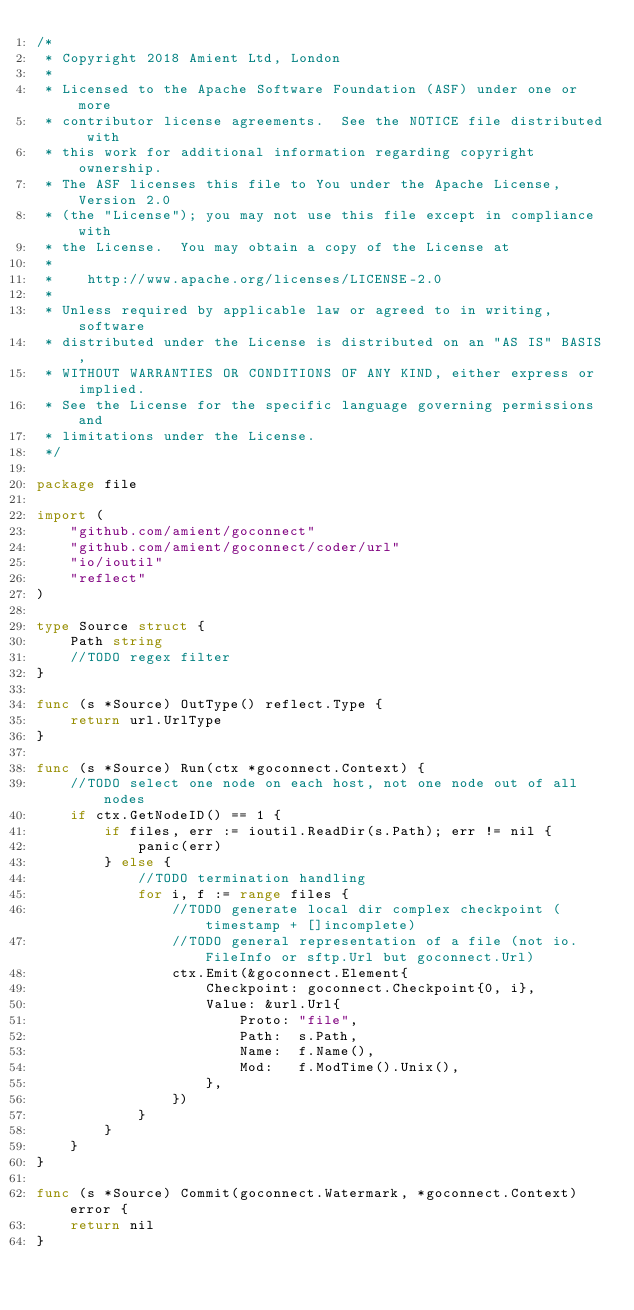Convert code to text. <code><loc_0><loc_0><loc_500><loc_500><_Go_>/*
 * Copyright 2018 Amient Ltd, London
 *
 * Licensed to the Apache Software Foundation (ASF) under one or more
 * contributor license agreements.  See the NOTICE file distributed with
 * this work for additional information regarding copyright ownership.
 * The ASF licenses this file to You under the Apache License, Version 2.0
 * (the "License"); you may not use this file except in compliance with
 * the License.  You may obtain a copy of the License at
 *
 *    http://www.apache.org/licenses/LICENSE-2.0
 *
 * Unless required by applicable law or agreed to in writing, software
 * distributed under the License is distributed on an "AS IS" BASIS,
 * WITHOUT WARRANTIES OR CONDITIONS OF ANY KIND, either express or implied.
 * See the License for the specific language governing permissions and
 * limitations under the License.
 */

package file

import (
	"github.com/amient/goconnect"
	"github.com/amient/goconnect/coder/url"
	"io/ioutil"
	"reflect"
)

type Source struct {
	Path string
	//TODO regex filter
}

func (s *Source) OutType() reflect.Type {
	return url.UrlType
}

func (s *Source) Run(ctx *goconnect.Context) {
	//TODO select one node on each host, not one node out of all nodes
	if ctx.GetNodeID() == 1 {
		if files, err := ioutil.ReadDir(s.Path); err != nil {
			panic(err)
		} else {
			//TODO termination handling
			for i, f := range files {
				//TODO generate local dir complex checkpoint (timestamp + []incomplete)
				//TODO general representation of a file (not io.FileInfo or sftp.Url but goconnect.Url)
				ctx.Emit(&goconnect.Element{
					Checkpoint: goconnect.Checkpoint{0, i},
					Value: &url.Url{
						Proto: "file",
						Path:  s.Path,
						Name:  f.Name(),
						Mod:   f.ModTime().Unix(),
					},
				})
			}
		}
	}
}

func (s *Source) Commit(goconnect.Watermark, *goconnect.Context) error {
	return nil
}
</code> 